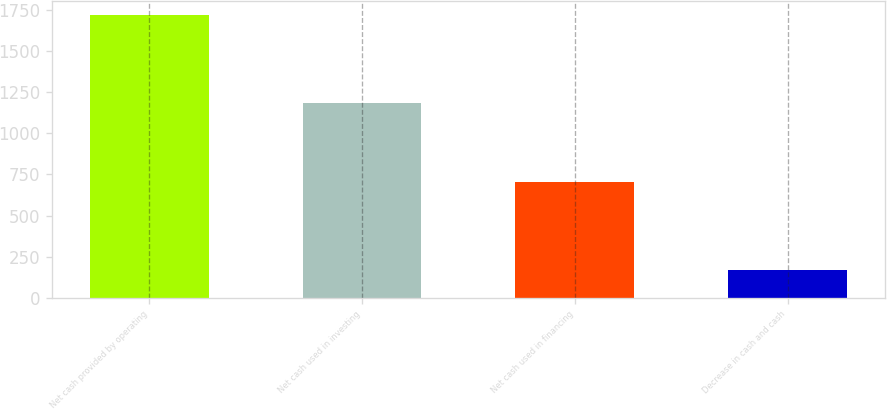<chart> <loc_0><loc_0><loc_500><loc_500><bar_chart><fcel>Net cash provided by operating<fcel>Net cash used in investing<fcel>Net cash used in financing<fcel>Decrease in cash and cash<nl><fcel>1716<fcel>1182<fcel>702<fcel>168<nl></chart> 